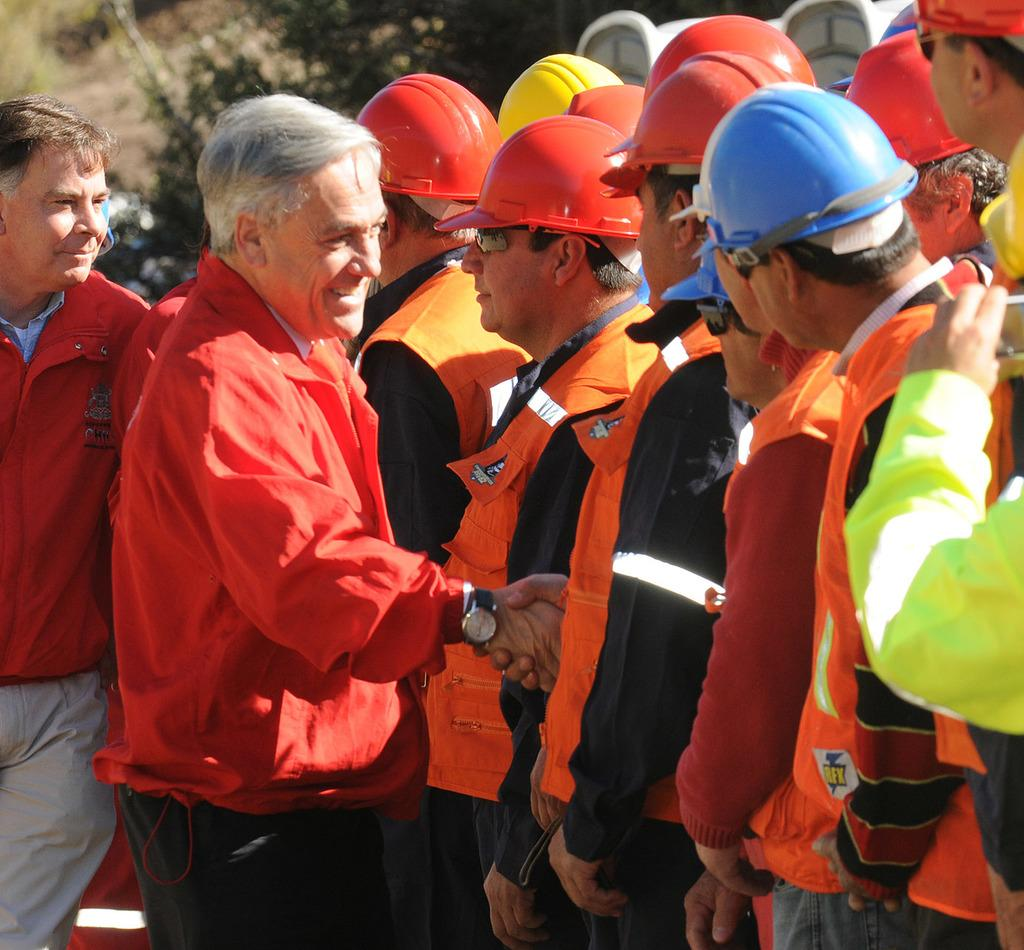What are the two people in the image doing? The two people in the image are shaking hands. Can you describe the person on the left side of the image? There is a person holding a camera in the image. What can be seen in the background of the image? There are trees in the background of the image. What type of insect can be seen crawling on the person holding the camera in the image? There are no insects visible in the image, and therefore no insects can be seen crawling on the person holding the camera. 